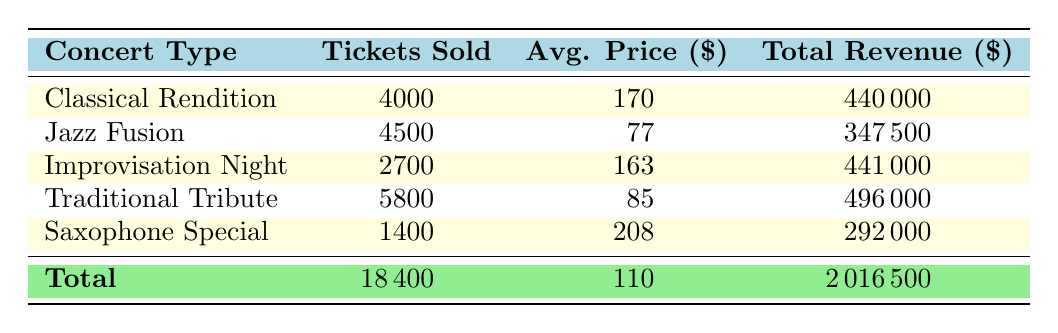What is the total number of tickets sold for the Classical Rendition concert type? In the table, under the Classical Rendition row, the Tickets Sold column shows a value of 4000.
Answer: 4000 Which concert type generated the highest total revenue? The Total Revenue column indicates that the Traditional Tribute concert type has the highest total revenue at 496000.
Answer: Traditional Tribute What is the average ticket price for the Saxophone Special concert type? For the Saxophone Special row, the Avg. Price column shows a value of 208, which comes from the Total Revenue of 292000 divided by the Tickets Sold of 1400.
Answer: 208 Are there more tickets sold for Jazz Fusion than for Improvisation Night? The Tickets Sold for Jazz Fusion is 4500 and for Improvisation Night is 2700. Since 4500 is greater than 2700, the answer is yes.
Answer: Yes What is the total revenue generated across all concert types? To find the total revenue, we sum all the values in the Total Revenue column: 440000 + 347500 + 441000 + 496000 + 292000 = 2016500.
Answer: 2016500 Which concert type has an average ticket price lower than 100? The Jazz Fusion and Traditional Tribute types have average prices of 77 and 85, respectively, both of which are lower than 100.
Answer: Jazz Fusion and Traditional Tribute What is the difference in total revenue between the Traditional Tribute and Saxophone Special concert types? The total revenue from the Traditional Tribute is 496000 and from the Saxophone Special is 292000. The difference is 496000 - 292000 = 204000.
Answer: 204000 How many tickets were sold in total across all concert types? The total tickets sold can be calculated by adding all the values in the Tickets Sold column: 4000 + 4500 + 2700 + 5800 + 1400 = 18400.
Answer: 18400 Is the average price of tickets for Improvisation Night greater than the average for Classical Rendition? The average price for Improvisation Night is 163 while for Classical Rendition it is 170. Since 163 is not greater than 170, the answer is no.
Answer: No 